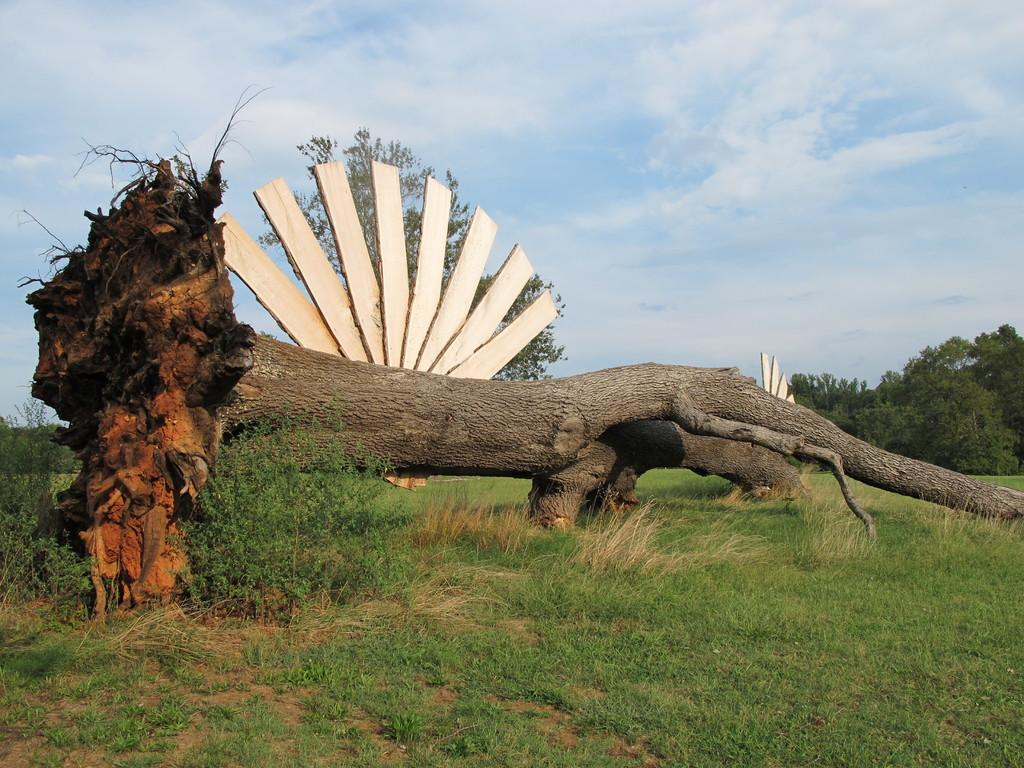What is the main object in the image? There is a tree trunk in the image. What other natural elements can be seen in the image? There are plants, grass, and trees in the image. What type of material is present in the image? There are wooden sheets in the image. What can be seen in the background of the image? The sky is visible in the background of the image. What type of cake is being served in the image? There is no cake present in the image. 